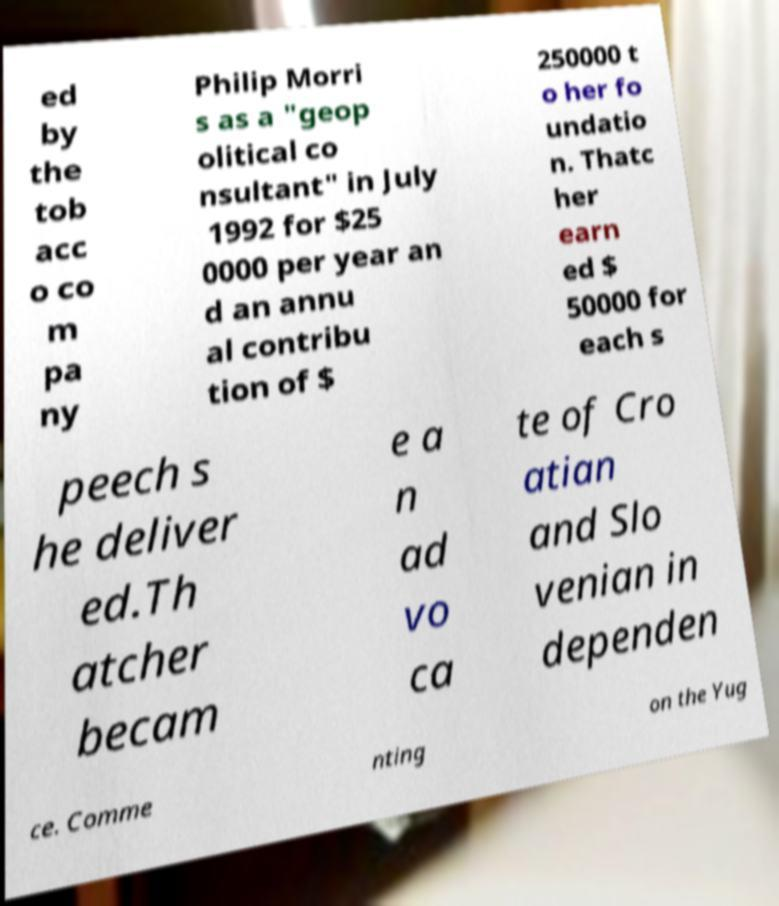Can you read and provide the text displayed in the image?This photo seems to have some interesting text. Can you extract and type it out for me? ed by the tob acc o co m pa ny Philip Morri s as a "geop olitical co nsultant" in July 1992 for $25 0000 per year an d an annu al contribu tion of $ 250000 t o her fo undatio n. Thatc her earn ed $ 50000 for each s peech s he deliver ed.Th atcher becam e a n ad vo ca te of Cro atian and Slo venian in dependen ce. Comme nting on the Yug 